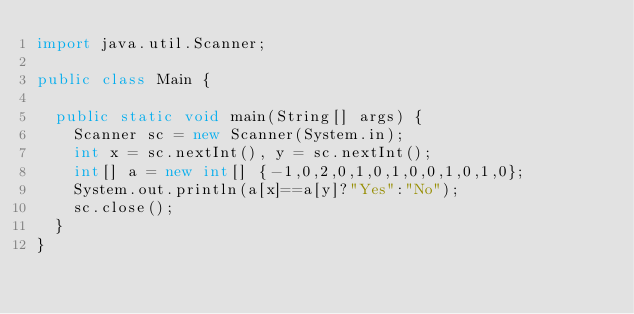Convert code to text. <code><loc_0><loc_0><loc_500><loc_500><_Java_>import java.util.Scanner;

public class Main {

	public static void main(String[] args) {
		Scanner sc = new Scanner(System.in);
		int x = sc.nextInt(), y = sc.nextInt();
		int[] a = new int[] {-1,0,2,0,1,0,1,0,0,1,0,1,0};
		System.out.println(a[x]==a[y]?"Yes":"No");
		sc.close();
	}
}</code> 